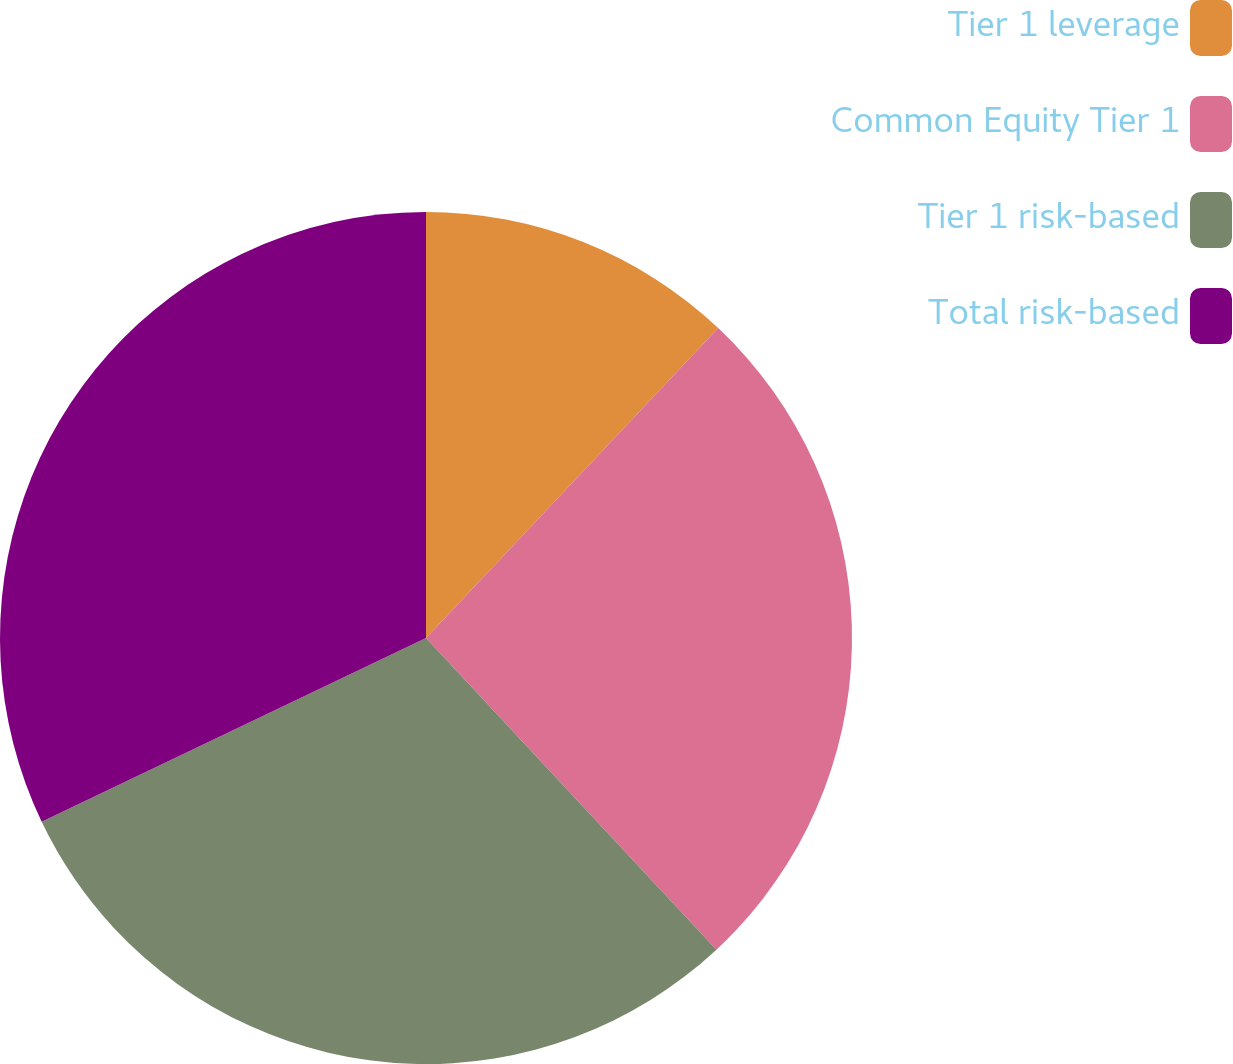<chart> <loc_0><loc_0><loc_500><loc_500><pie_chart><fcel>Tier 1 leverage<fcel>Common Equity Tier 1<fcel>Tier 1 risk-based<fcel>Total risk-based<nl><fcel>12.03%<fcel>26.03%<fcel>29.84%<fcel>32.1%<nl></chart> 